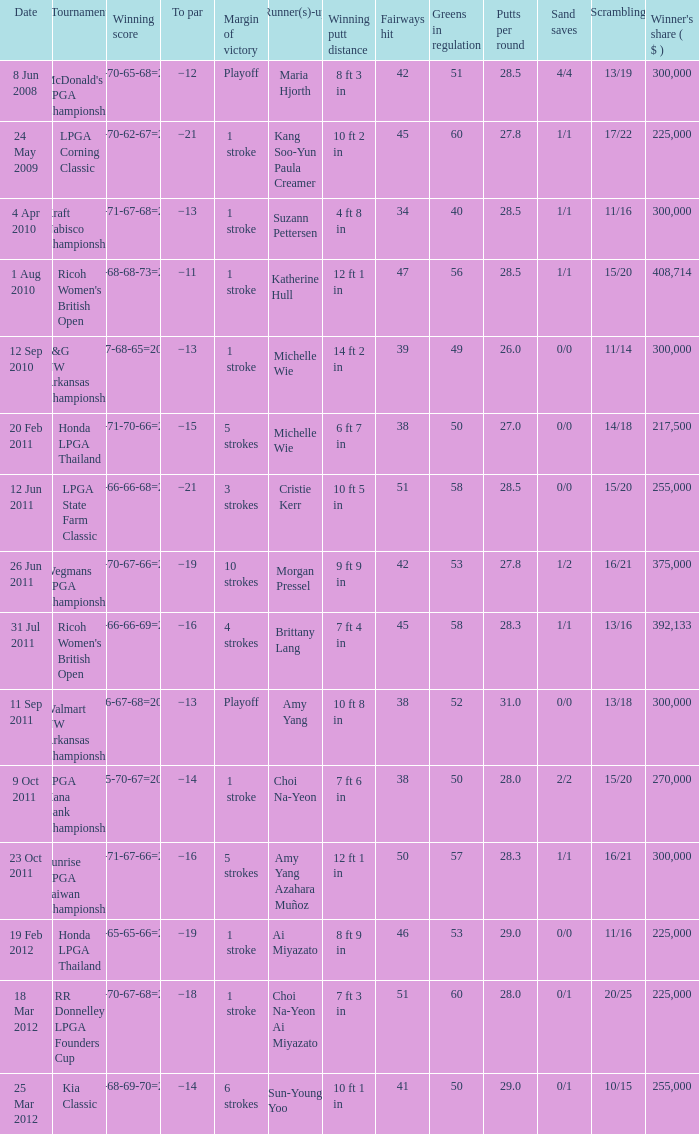Who was the runner-up in the RR Donnelley LPGA Founders Cup? Choi Na-Yeon Ai Miyazato. 